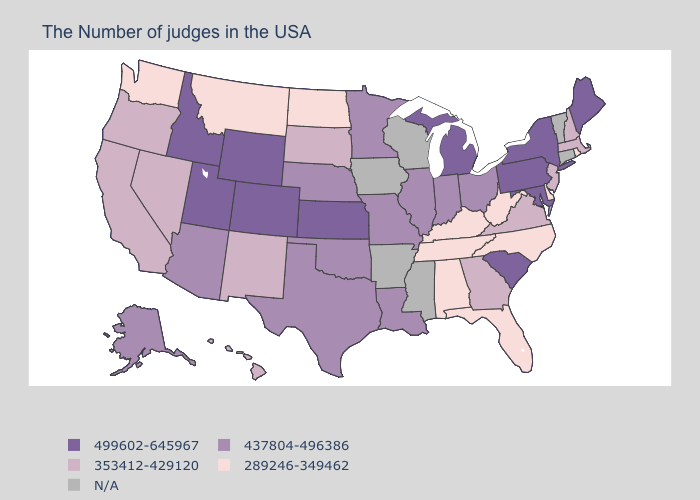Does Utah have the highest value in the USA?
Be succinct. Yes. What is the highest value in states that border Maine?
Short answer required. 353412-429120. Name the states that have a value in the range 353412-429120?
Short answer required. Massachusetts, New Hampshire, New Jersey, Virginia, Georgia, South Dakota, New Mexico, Nevada, California, Oregon, Hawaii. What is the value of Utah?
Keep it brief. 499602-645967. Name the states that have a value in the range 499602-645967?
Quick response, please. Maine, New York, Maryland, Pennsylvania, South Carolina, Michigan, Kansas, Wyoming, Colorado, Utah, Idaho. Among the states that border South Carolina , does North Carolina have the highest value?
Give a very brief answer. No. What is the lowest value in the USA?
Short answer required. 289246-349462. What is the lowest value in the USA?
Keep it brief. 289246-349462. Which states hav the highest value in the MidWest?
Quick response, please. Michigan, Kansas. Does the map have missing data?
Be succinct. Yes. What is the highest value in the USA?
Be succinct. 499602-645967. What is the value of Nevada?
Quick response, please. 353412-429120. 